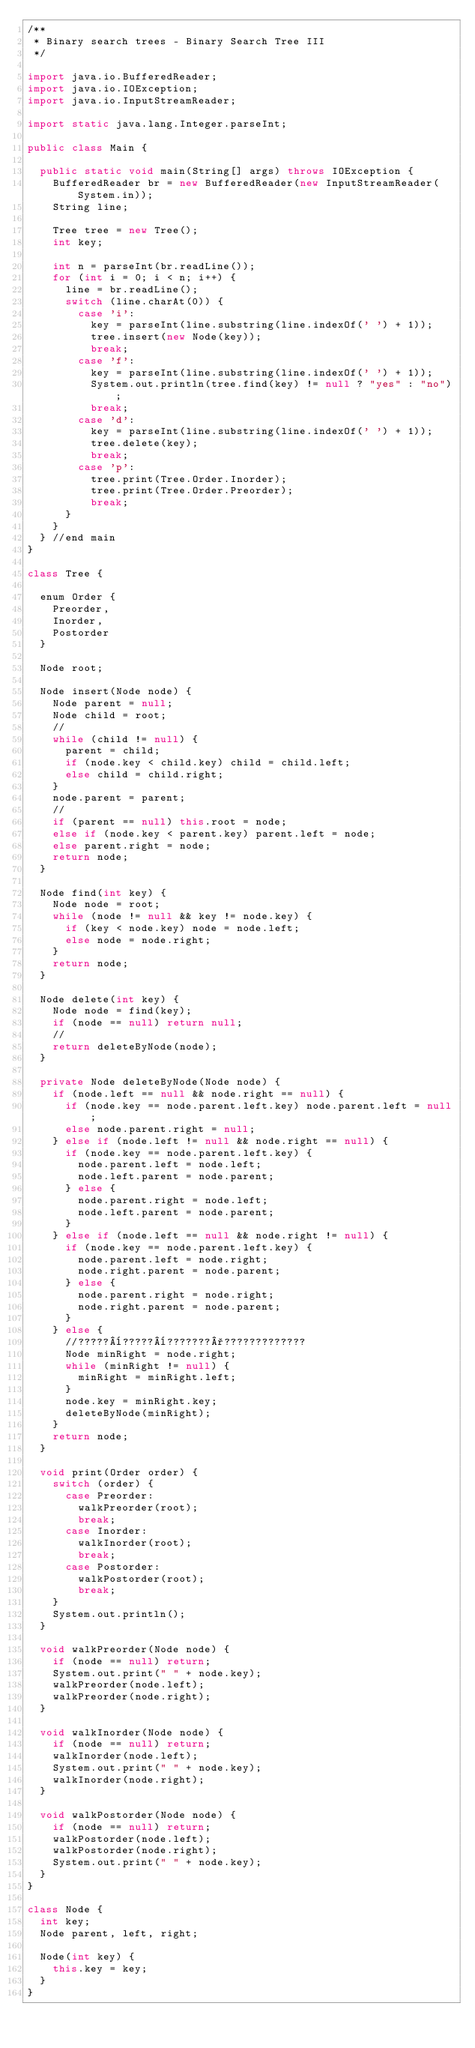<code> <loc_0><loc_0><loc_500><loc_500><_Java_>/**
 * Binary search trees - Binary Search Tree III
 */

import java.io.BufferedReader;
import java.io.IOException;
import java.io.InputStreamReader;

import static java.lang.Integer.parseInt;

public class Main {

	public static void main(String[] args) throws IOException {
		BufferedReader br = new BufferedReader(new InputStreamReader(System.in));
		String line;

		Tree tree = new Tree();
		int key;

		int n = parseInt(br.readLine());
		for (int i = 0; i < n; i++) {
			line = br.readLine();
			switch (line.charAt(0)) {
				case 'i':
					key = parseInt(line.substring(line.indexOf(' ') + 1));
					tree.insert(new Node(key));
					break;
				case 'f':
					key = parseInt(line.substring(line.indexOf(' ') + 1));
					System.out.println(tree.find(key) != null ? "yes" : "no");
					break;
				case 'd':
					key = parseInt(line.substring(line.indexOf(' ') + 1));
					tree.delete(key);
					break;
				case 'p':
					tree.print(Tree.Order.Inorder);
					tree.print(Tree.Order.Preorder);
					break;
			}
		}
	} //end main
}

class Tree {

	enum Order {
		Preorder,
		Inorder,
		Postorder
	}

	Node root;

	Node insert(Node node) {
		Node parent = null;
		Node child = root;
		//
		while (child != null) {
			parent = child;
			if (node.key < child.key) child = child.left;
			else child = child.right;
		}
		node.parent = parent;
		//
		if (parent == null) this.root = node;
		else if (node.key < parent.key) parent.left = node;
		else parent.right = node;
		return node;
	}

	Node find(int key) {
		Node node = root;
		while (node != null && key != node.key) {
			if (key < node.key) node = node.left;
			else node = node.right;
		}
		return node;
	}

	Node delete(int key) {
		Node node = find(key);
		if (node == null) return null;
		//
		return deleteByNode(node);
	}

	private Node deleteByNode(Node node) {
		if (node.left == null && node.right == null) {
			if (node.key == node.parent.left.key) node.parent.left = null;
			else node.parent.right = null;
		} else if (node.left != null && node.right == null) {
			if (node.key == node.parent.left.key) {
				node.parent.left = node.left;
				node.left.parent = node.parent;
			} else {
				node.parent.right = node.left;
				node.left.parent = node.parent;
			}
		} else if (node.left == null && node.right != null) {
			if (node.key == node.parent.left.key) {
				node.parent.left = node.right;
				node.right.parent = node.parent;
			} else {
				node.parent.right = node.right;
				node.right.parent = node.parent;
			}
		} else {
			//?????¨?????¨???????°?????????????
			Node minRight = node.right;
			while (minRight != null) {
				minRight = minRight.left;
			}
			node.key = minRight.key;
			deleteByNode(minRight);
		}
		return node;
	}

	void print(Order order) {
		switch (order) {
			case Preorder:
				walkPreorder(root);
				break;
			case Inorder:
				walkInorder(root);
				break;
			case Postorder:
				walkPostorder(root);
				break;
		}
		System.out.println();
	}

	void walkPreorder(Node node) {
		if (node == null) return;
		System.out.print(" " + node.key);
		walkPreorder(node.left);
		walkPreorder(node.right);
	}

	void walkInorder(Node node) {
		if (node == null) return;
		walkInorder(node.left);
		System.out.print(" " + node.key);
		walkInorder(node.right);
	}

	void walkPostorder(Node node) {
		if (node == null) return;
		walkPostorder(node.left);
		walkPostorder(node.right);
		System.out.print(" " + node.key);
	}
}

class Node {
	int key;
	Node parent, left, right;

	Node(int key) {
		this.key = key;
	}
}</code> 